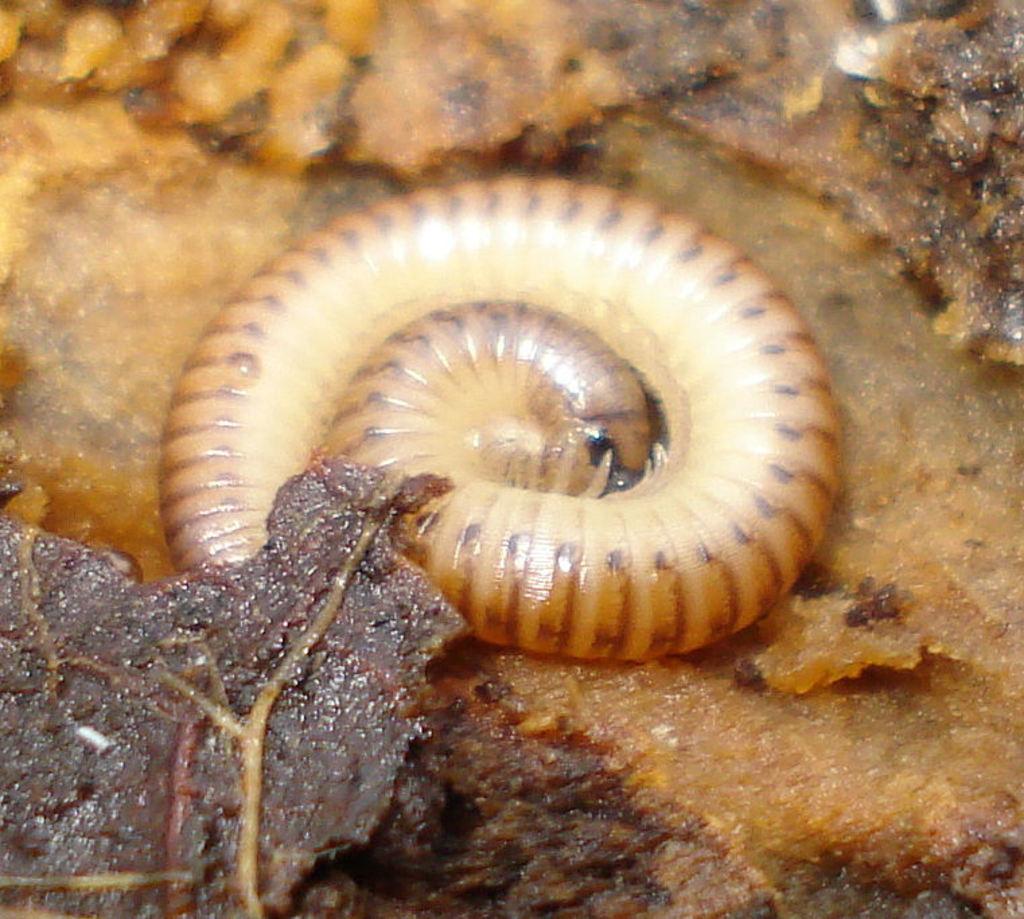Can you describe this image briefly? In this picture we can see an insect on a surface. 